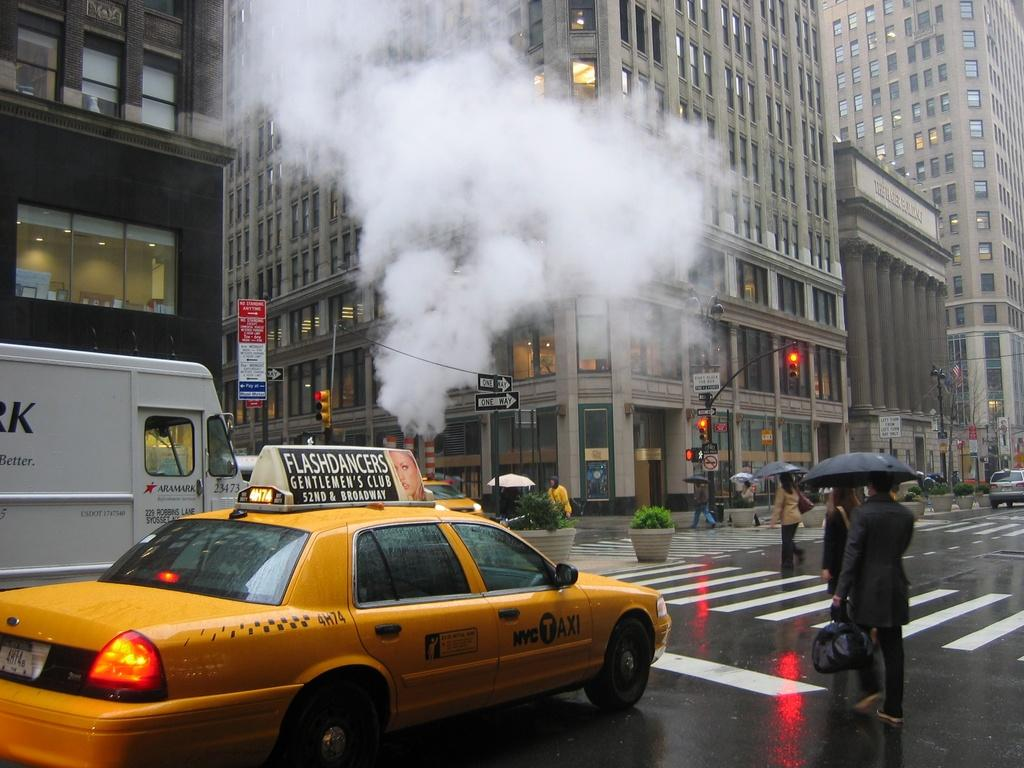<image>
Describe the image concisely. A yellow taxi cab next to a busy cross walk with a flashdancers on top of the cab. 